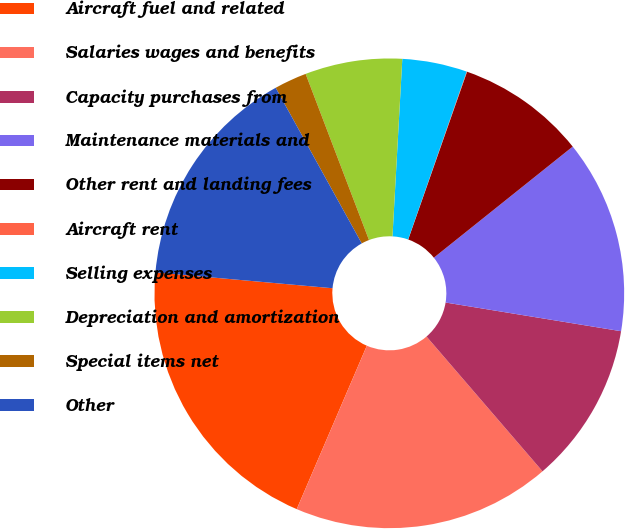Convert chart to OTSL. <chart><loc_0><loc_0><loc_500><loc_500><pie_chart><fcel>Aircraft fuel and related<fcel>Salaries wages and benefits<fcel>Capacity purchases from<fcel>Maintenance materials and<fcel>Other rent and landing fees<fcel>Aircraft rent<fcel>Selling expenses<fcel>Depreciation and amortization<fcel>Special items net<fcel>Other<nl><fcel>19.97%<fcel>17.76%<fcel>11.11%<fcel>13.32%<fcel>8.89%<fcel>0.03%<fcel>4.46%<fcel>6.68%<fcel>2.24%<fcel>15.54%<nl></chart> 